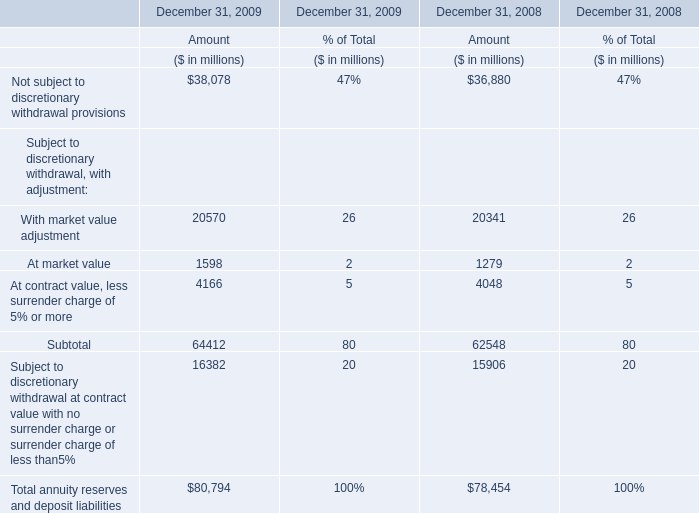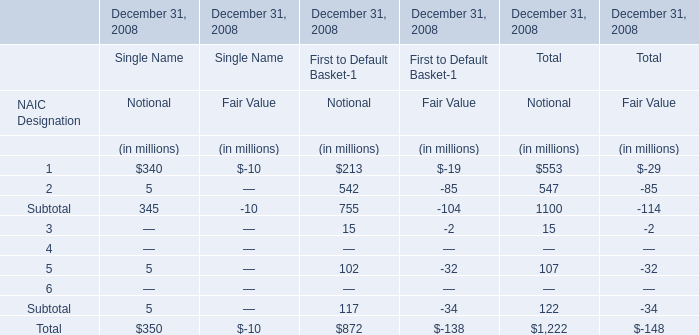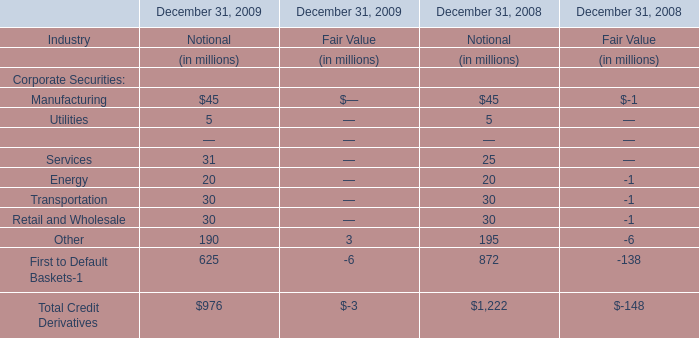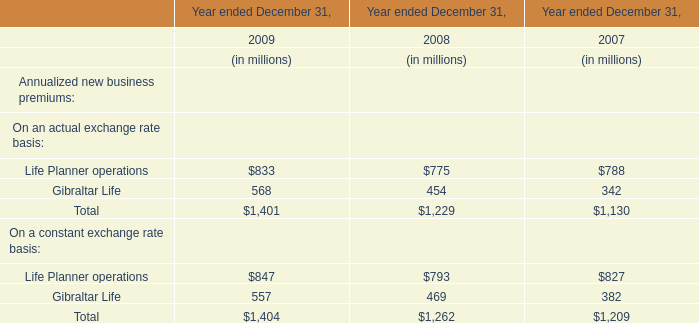What is the total value of 1, 2, 3 and 5 in 2018 for Total for Notional? (in million) 
Computations: (((553 + 547) + 15) + 107)
Answer: 1222.0. 